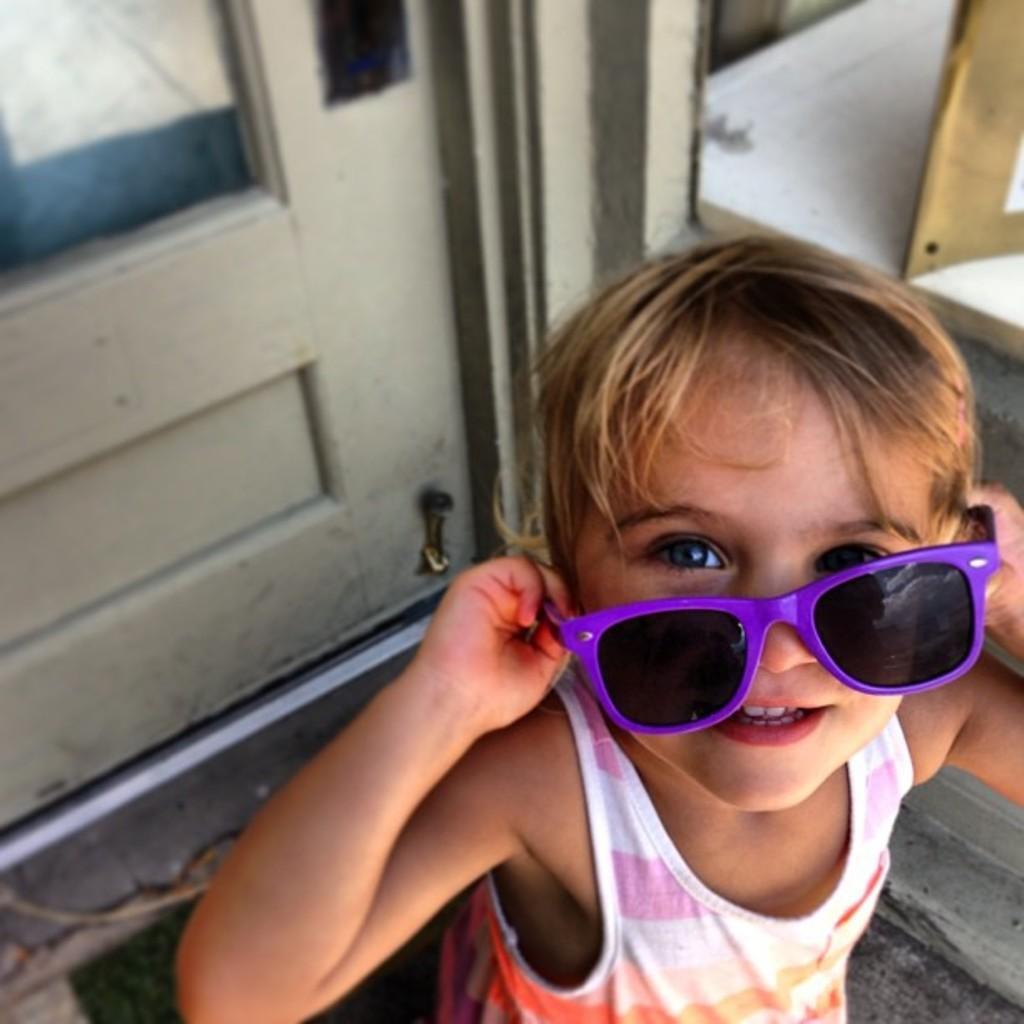Could you give a brief overview of what you see in this image? In the picture we can see a child standing and holding a shades which are black in color with a violet frame and in the background of the picture we can see a door which is white in color with a glass and a doormat near the door and beside to it we can see a white color plank and something placed on it. 